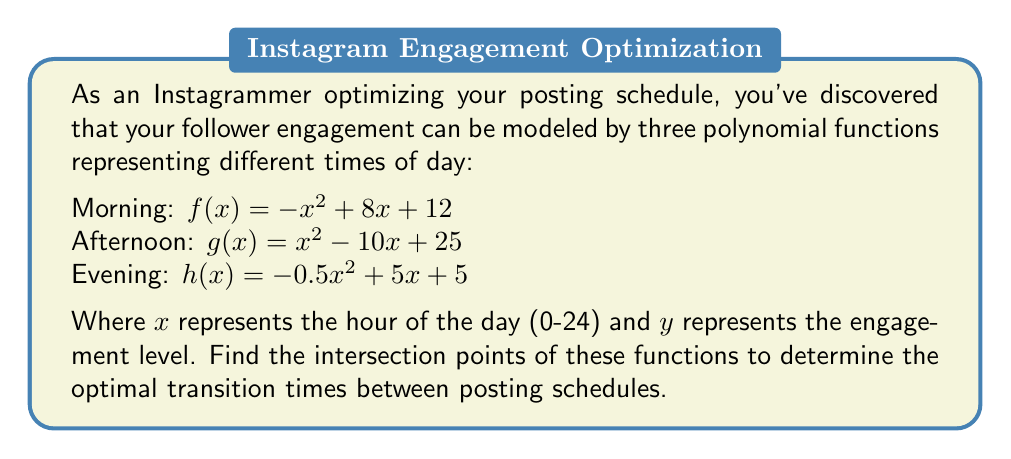Provide a solution to this math problem. To find the intersection points, we need to solve the equations where the functions are equal to each other:

1. Morning and Afternoon intersection:
   $f(x) = g(x)$
   $-x^2 + 8x + 12 = x^2 - 10x + 25$
   $-2x^2 + 18x - 13 = 0$
   $-(2x^2 - 18x + 13) = 0$
   $-(2(x^2 - 9x + \frac{13}{2})) = 0$
   $-(2(x - \frac{13}{2})(x - \frac{5}{2})) = 0$
   $x = \frac{13}{2}$ or $x = \frac{5}{2}$

2. Afternoon and Evening intersection:
   $g(x) = h(x)$
   $x^2 - 10x + 25 = -0.5x^2 + 5x + 5$
   $1.5x^2 - 15x + 20 = 0$
   $3x^2 - 30x + 40 = 0$
   $3(x^2 - 10x + \frac{40}{3}) = 0$
   $3(x - \frac{10}{3})(x - 2) = 0$
   $x = \frac{10}{3}$ or $x = 2$

3. Morning and Evening intersection:
   $f(x) = h(x)$
   $-x^2 + 8x + 12 = -0.5x^2 + 5x + 5$
   $-0.5x^2 + 3x + 7 = 0$
   $-(x^2 - 6x - 14) = 0$
   $-(x - 7)(x + 1) = 0$
   $x = 7$ or $x = -1$ (discard as it's outside the valid range)

The valid intersection points are at $x = \frac{5}{2}, \frac{10}{3}, \frac{13}{2},$ and $7$.
Answer: $(\frac{5}{2}, 22), (\frac{10}{3}, \frac{55}{3}), (\frac{13}{2}, \frac{63}{2}), (7, 33)$ 